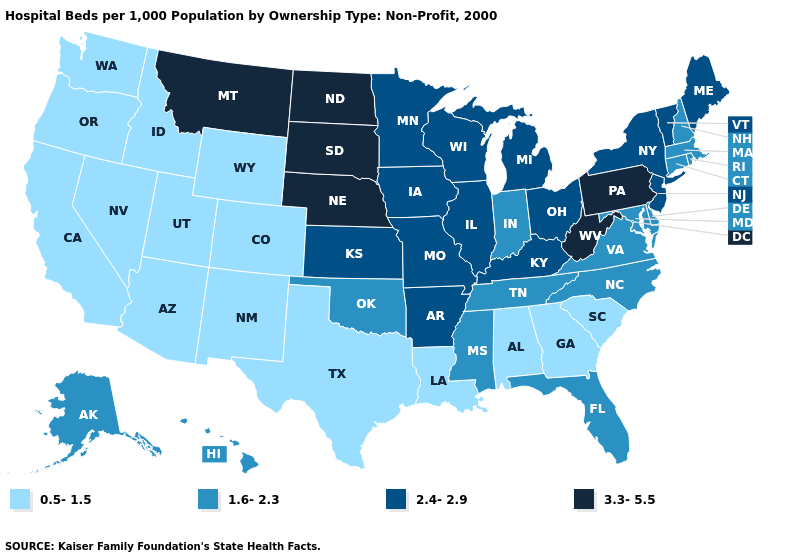What is the value of Wyoming?
Write a very short answer. 0.5-1.5. Which states have the lowest value in the USA?
Be succinct. Alabama, Arizona, California, Colorado, Georgia, Idaho, Louisiana, Nevada, New Mexico, Oregon, South Carolina, Texas, Utah, Washington, Wyoming. Name the states that have a value in the range 0.5-1.5?
Keep it brief. Alabama, Arizona, California, Colorado, Georgia, Idaho, Louisiana, Nevada, New Mexico, Oregon, South Carolina, Texas, Utah, Washington, Wyoming. What is the value of Michigan?
Give a very brief answer. 2.4-2.9. What is the value of Michigan?
Be succinct. 2.4-2.9. Name the states that have a value in the range 2.4-2.9?
Be succinct. Arkansas, Illinois, Iowa, Kansas, Kentucky, Maine, Michigan, Minnesota, Missouri, New Jersey, New York, Ohio, Vermont, Wisconsin. Name the states that have a value in the range 1.6-2.3?
Answer briefly. Alaska, Connecticut, Delaware, Florida, Hawaii, Indiana, Maryland, Massachusetts, Mississippi, New Hampshire, North Carolina, Oklahoma, Rhode Island, Tennessee, Virginia. What is the lowest value in states that border Arkansas?
Short answer required. 0.5-1.5. Which states have the lowest value in the USA?
Keep it brief. Alabama, Arizona, California, Colorado, Georgia, Idaho, Louisiana, Nevada, New Mexico, Oregon, South Carolina, Texas, Utah, Washington, Wyoming. What is the lowest value in states that border Kansas?
Answer briefly. 0.5-1.5. Which states have the highest value in the USA?
Give a very brief answer. Montana, Nebraska, North Dakota, Pennsylvania, South Dakota, West Virginia. Among the states that border South Carolina , does North Carolina have the highest value?
Be succinct. Yes. What is the value of Montana?
Give a very brief answer. 3.3-5.5. Does Nevada have the same value as Washington?
Short answer required. Yes. 